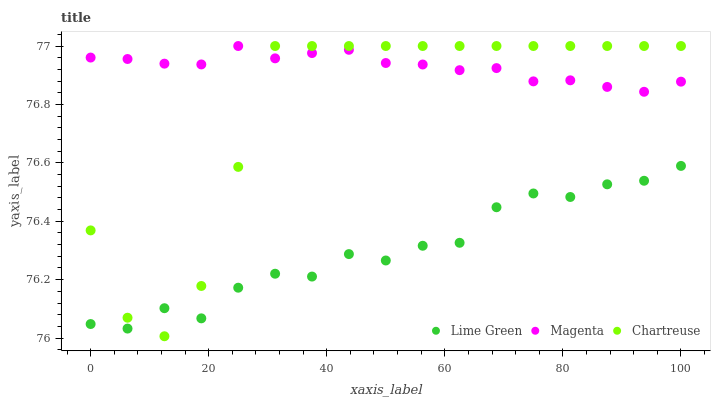Does Lime Green have the minimum area under the curve?
Answer yes or no. Yes. Does Magenta have the maximum area under the curve?
Answer yes or no. Yes. Does Chartreuse have the minimum area under the curve?
Answer yes or no. No. Does Chartreuse have the maximum area under the curve?
Answer yes or no. No. Is Magenta the smoothest?
Answer yes or no. Yes. Is Chartreuse the roughest?
Answer yes or no. Yes. Is Lime Green the smoothest?
Answer yes or no. No. Is Lime Green the roughest?
Answer yes or no. No. Does Chartreuse have the lowest value?
Answer yes or no. Yes. Does Lime Green have the lowest value?
Answer yes or no. No. Does Chartreuse have the highest value?
Answer yes or no. Yes. Does Lime Green have the highest value?
Answer yes or no. No. Is Lime Green less than Magenta?
Answer yes or no. Yes. Is Magenta greater than Lime Green?
Answer yes or no. Yes. Does Magenta intersect Chartreuse?
Answer yes or no. Yes. Is Magenta less than Chartreuse?
Answer yes or no. No. Is Magenta greater than Chartreuse?
Answer yes or no. No. Does Lime Green intersect Magenta?
Answer yes or no. No. 